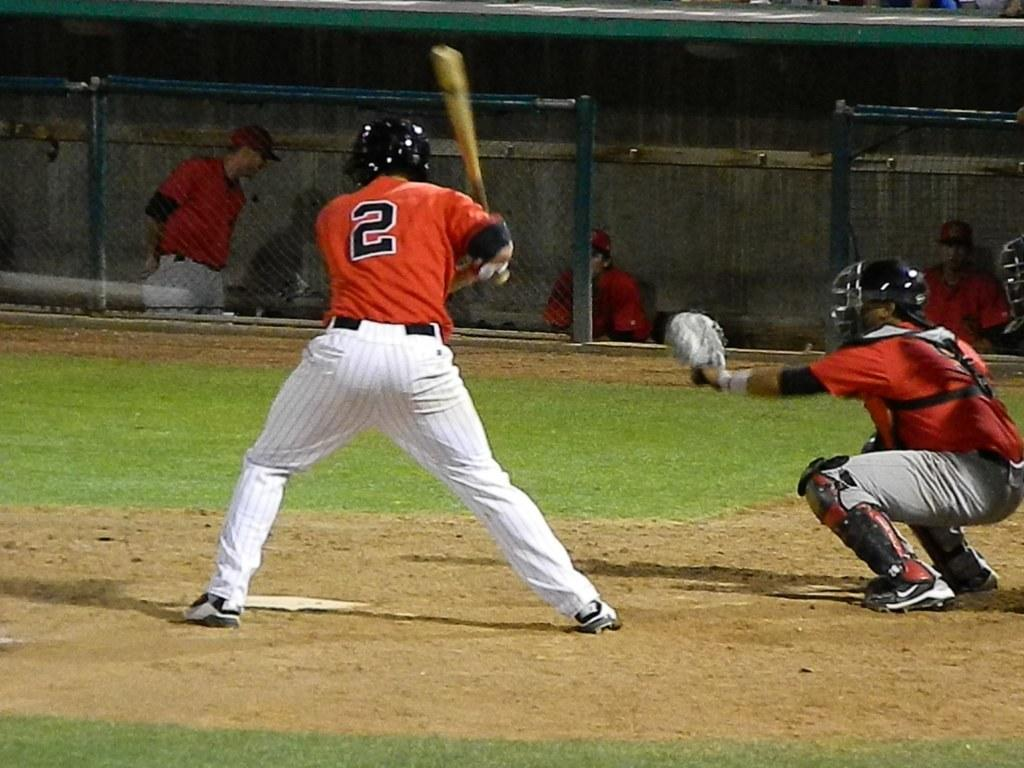<image>
Give a short and clear explanation of the subsequent image. A baseball player in an orange jersey with the number 2 prepares to swing at the ball. 